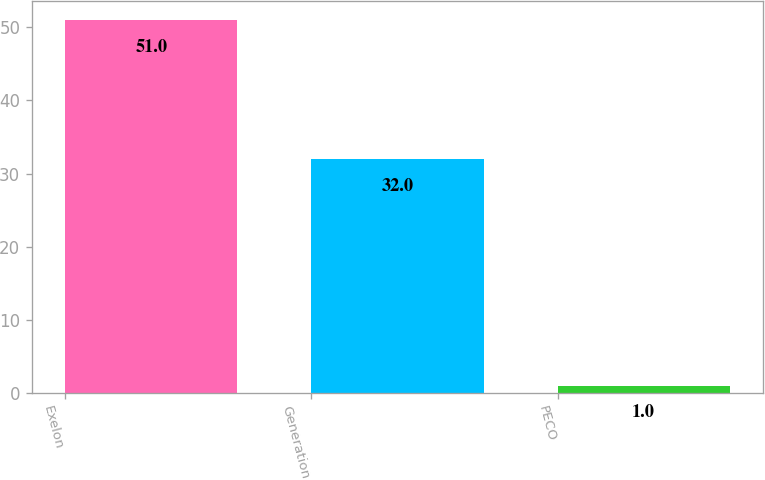Convert chart to OTSL. <chart><loc_0><loc_0><loc_500><loc_500><bar_chart><fcel>Exelon<fcel>Generation<fcel>PECO<nl><fcel>51<fcel>32<fcel>1<nl></chart> 